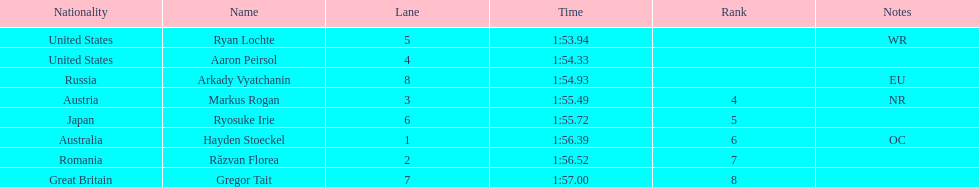How many names are listed? 8. 